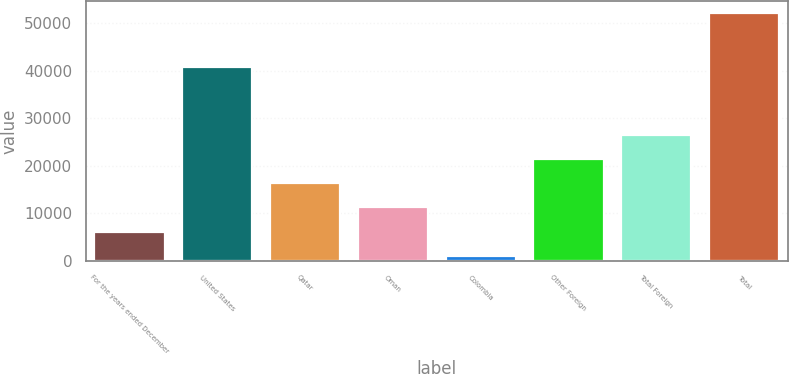<chart> <loc_0><loc_0><loc_500><loc_500><bar_chart><fcel>For the years ended December<fcel>United States<fcel>Qatar<fcel>Oman<fcel>Colombia<fcel>Other Foreign<fcel>Total Foreign<fcel>Total<nl><fcel>6143.3<fcel>40786<fcel>16347.9<fcel>11245.6<fcel>1041<fcel>21450.2<fcel>26552.5<fcel>52064<nl></chart> 